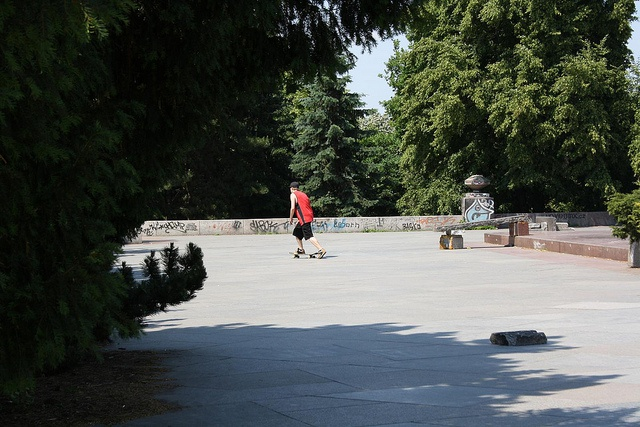Describe the objects in this image and their specific colors. I can see people in black, lightgray, salmon, and gray tones and skateboard in black, lightgray, darkgray, and gray tones in this image. 